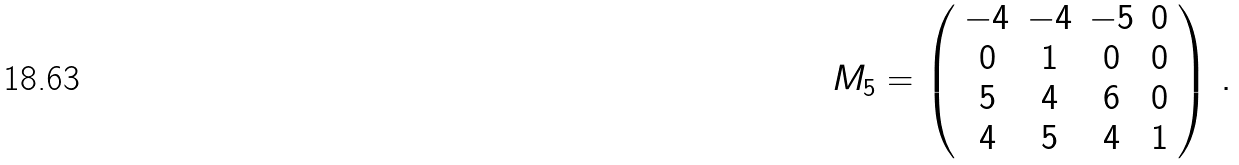Convert formula to latex. <formula><loc_0><loc_0><loc_500><loc_500>M _ { 5 } = \left ( \begin{array} { c c c c } - 4 & - 4 & - 5 & 0 \\ 0 & 1 & 0 & 0 \\ 5 & 4 & 6 & 0 \\ 4 & 5 & 4 & 1 \end{array} \right ) \, .</formula> 